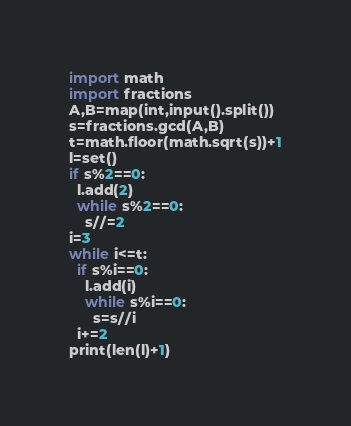<code> <loc_0><loc_0><loc_500><loc_500><_Python_>import math
import fractions
A,B=map(int,input().split())
s=fractions.gcd(A,B)
t=math.floor(math.sqrt(s))+1
l=set()
if s%2==0:
  l.add(2)
  while s%2==0:
    s//=2
i=3
while i<=t:
  if s%i==0:
    l.add(i)
    while s%i==0:
      s=s//i
  i+=2
print(len(l)+1)</code> 